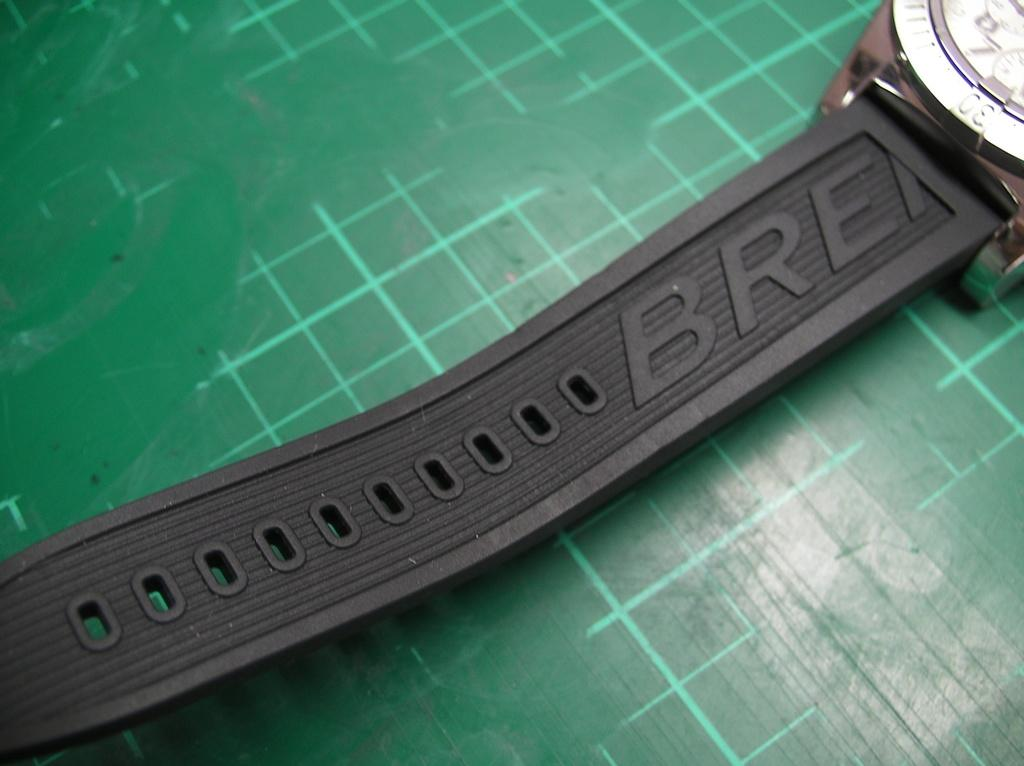<image>
Offer a succinct explanation of the picture presented. green grid with a watch on it that has BRE on the band 